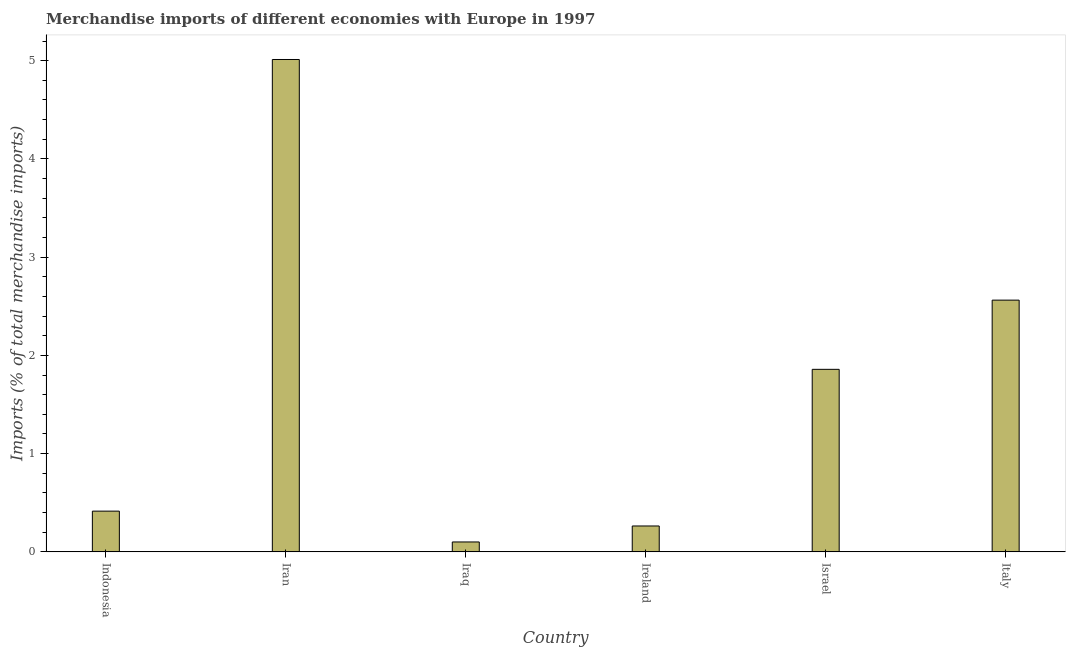Does the graph contain any zero values?
Offer a very short reply. No. Does the graph contain grids?
Offer a terse response. No. What is the title of the graph?
Provide a succinct answer. Merchandise imports of different economies with Europe in 1997. What is the label or title of the X-axis?
Provide a succinct answer. Country. What is the label or title of the Y-axis?
Give a very brief answer. Imports (% of total merchandise imports). What is the merchandise imports in Iraq?
Ensure brevity in your answer.  0.1. Across all countries, what is the maximum merchandise imports?
Offer a terse response. 5.01. Across all countries, what is the minimum merchandise imports?
Make the answer very short. 0.1. In which country was the merchandise imports maximum?
Make the answer very short. Iran. In which country was the merchandise imports minimum?
Your answer should be compact. Iraq. What is the sum of the merchandise imports?
Provide a succinct answer. 10.21. What is the difference between the merchandise imports in Indonesia and Iraq?
Offer a terse response. 0.31. What is the average merchandise imports per country?
Provide a succinct answer. 1.7. What is the median merchandise imports?
Offer a very short reply. 1.14. What is the ratio of the merchandise imports in Indonesia to that in Iran?
Make the answer very short. 0.08. Is the difference between the merchandise imports in Iraq and Italy greater than the difference between any two countries?
Keep it short and to the point. No. What is the difference between the highest and the second highest merchandise imports?
Provide a short and direct response. 2.45. Is the sum of the merchandise imports in Iran and Israel greater than the maximum merchandise imports across all countries?
Your answer should be very brief. Yes. What is the difference between the highest and the lowest merchandise imports?
Your answer should be very brief. 4.91. In how many countries, is the merchandise imports greater than the average merchandise imports taken over all countries?
Your answer should be compact. 3. How many countries are there in the graph?
Provide a short and direct response. 6. What is the Imports (% of total merchandise imports) of Indonesia?
Provide a succinct answer. 0.41. What is the Imports (% of total merchandise imports) in Iran?
Your answer should be compact. 5.01. What is the Imports (% of total merchandise imports) in Iraq?
Offer a terse response. 0.1. What is the Imports (% of total merchandise imports) of Ireland?
Make the answer very short. 0.26. What is the Imports (% of total merchandise imports) of Israel?
Make the answer very short. 1.86. What is the Imports (% of total merchandise imports) in Italy?
Provide a succinct answer. 2.56. What is the difference between the Imports (% of total merchandise imports) in Indonesia and Iran?
Keep it short and to the point. -4.6. What is the difference between the Imports (% of total merchandise imports) in Indonesia and Iraq?
Your response must be concise. 0.31. What is the difference between the Imports (% of total merchandise imports) in Indonesia and Ireland?
Your answer should be very brief. 0.15. What is the difference between the Imports (% of total merchandise imports) in Indonesia and Israel?
Ensure brevity in your answer.  -1.44. What is the difference between the Imports (% of total merchandise imports) in Indonesia and Italy?
Ensure brevity in your answer.  -2.15. What is the difference between the Imports (% of total merchandise imports) in Iran and Iraq?
Provide a short and direct response. 4.91. What is the difference between the Imports (% of total merchandise imports) in Iran and Ireland?
Your answer should be very brief. 4.75. What is the difference between the Imports (% of total merchandise imports) in Iran and Israel?
Provide a short and direct response. 3.15. What is the difference between the Imports (% of total merchandise imports) in Iran and Italy?
Your answer should be compact. 2.45. What is the difference between the Imports (% of total merchandise imports) in Iraq and Ireland?
Your response must be concise. -0.16. What is the difference between the Imports (% of total merchandise imports) in Iraq and Israel?
Provide a short and direct response. -1.76. What is the difference between the Imports (% of total merchandise imports) in Iraq and Italy?
Ensure brevity in your answer.  -2.46. What is the difference between the Imports (% of total merchandise imports) in Ireland and Israel?
Offer a very short reply. -1.59. What is the difference between the Imports (% of total merchandise imports) in Ireland and Italy?
Keep it short and to the point. -2.3. What is the difference between the Imports (% of total merchandise imports) in Israel and Italy?
Offer a very short reply. -0.7. What is the ratio of the Imports (% of total merchandise imports) in Indonesia to that in Iran?
Make the answer very short. 0.08. What is the ratio of the Imports (% of total merchandise imports) in Indonesia to that in Iraq?
Your response must be concise. 4.11. What is the ratio of the Imports (% of total merchandise imports) in Indonesia to that in Ireland?
Your answer should be very brief. 1.57. What is the ratio of the Imports (% of total merchandise imports) in Indonesia to that in Israel?
Give a very brief answer. 0.22. What is the ratio of the Imports (% of total merchandise imports) in Indonesia to that in Italy?
Make the answer very short. 0.16. What is the ratio of the Imports (% of total merchandise imports) in Iran to that in Iraq?
Your answer should be compact. 49.66. What is the ratio of the Imports (% of total merchandise imports) in Iran to that in Ireland?
Offer a terse response. 19.02. What is the ratio of the Imports (% of total merchandise imports) in Iran to that in Israel?
Provide a succinct answer. 2.7. What is the ratio of the Imports (% of total merchandise imports) in Iran to that in Italy?
Provide a succinct answer. 1.96. What is the ratio of the Imports (% of total merchandise imports) in Iraq to that in Ireland?
Keep it short and to the point. 0.38. What is the ratio of the Imports (% of total merchandise imports) in Iraq to that in Israel?
Offer a terse response. 0.05. What is the ratio of the Imports (% of total merchandise imports) in Iraq to that in Italy?
Make the answer very short. 0.04. What is the ratio of the Imports (% of total merchandise imports) in Ireland to that in Israel?
Give a very brief answer. 0.14. What is the ratio of the Imports (% of total merchandise imports) in Ireland to that in Italy?
Your response must be concise. 0.1. What is the ratio of the Imports (% of total merchandise imports) in Israel to that in Italy?
Your response must be concise. 0.72. 